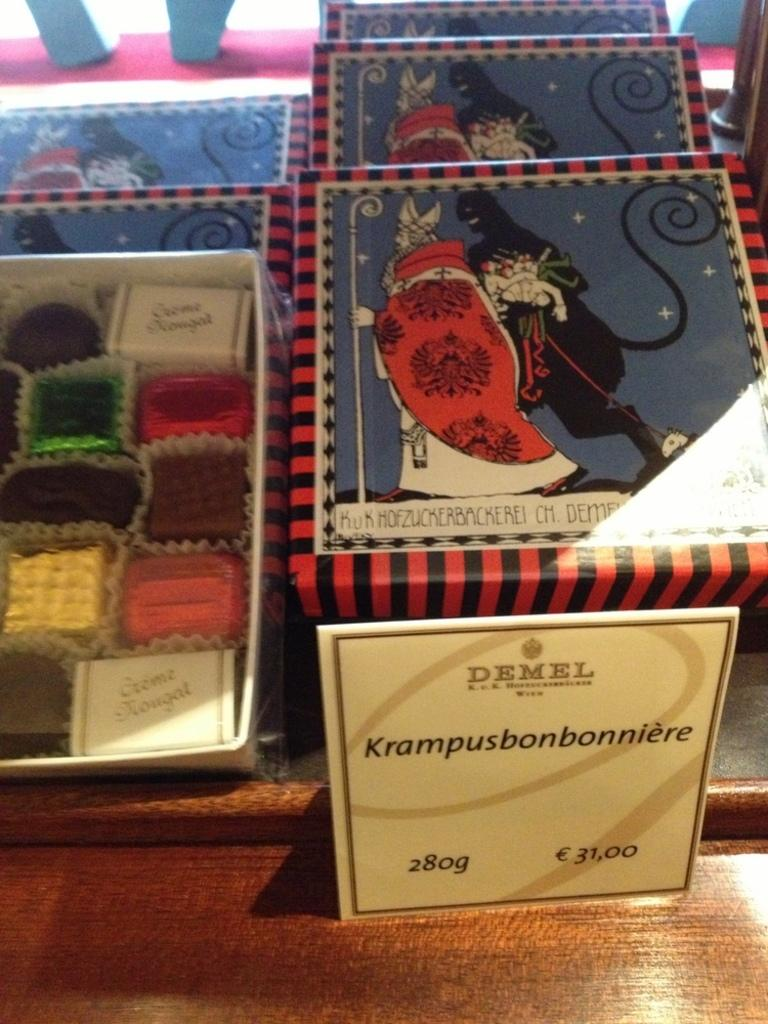Provide a one-sentence caption for the provided image. Holiday boxes full of Demel brand chocolates in individual wrappers. 